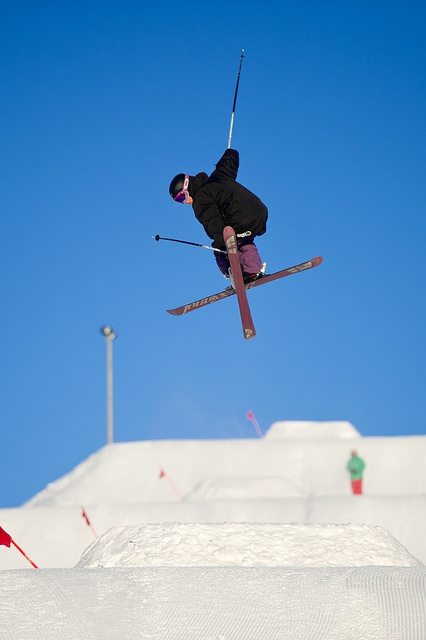Describe the objects in this image and their specific colors. I can see people in blue, black, purple, and gray tones, skis in blue, brown, and gray tones, and people in blue, turquoise, darkgray, salmon, and lightpink tones in this image. 